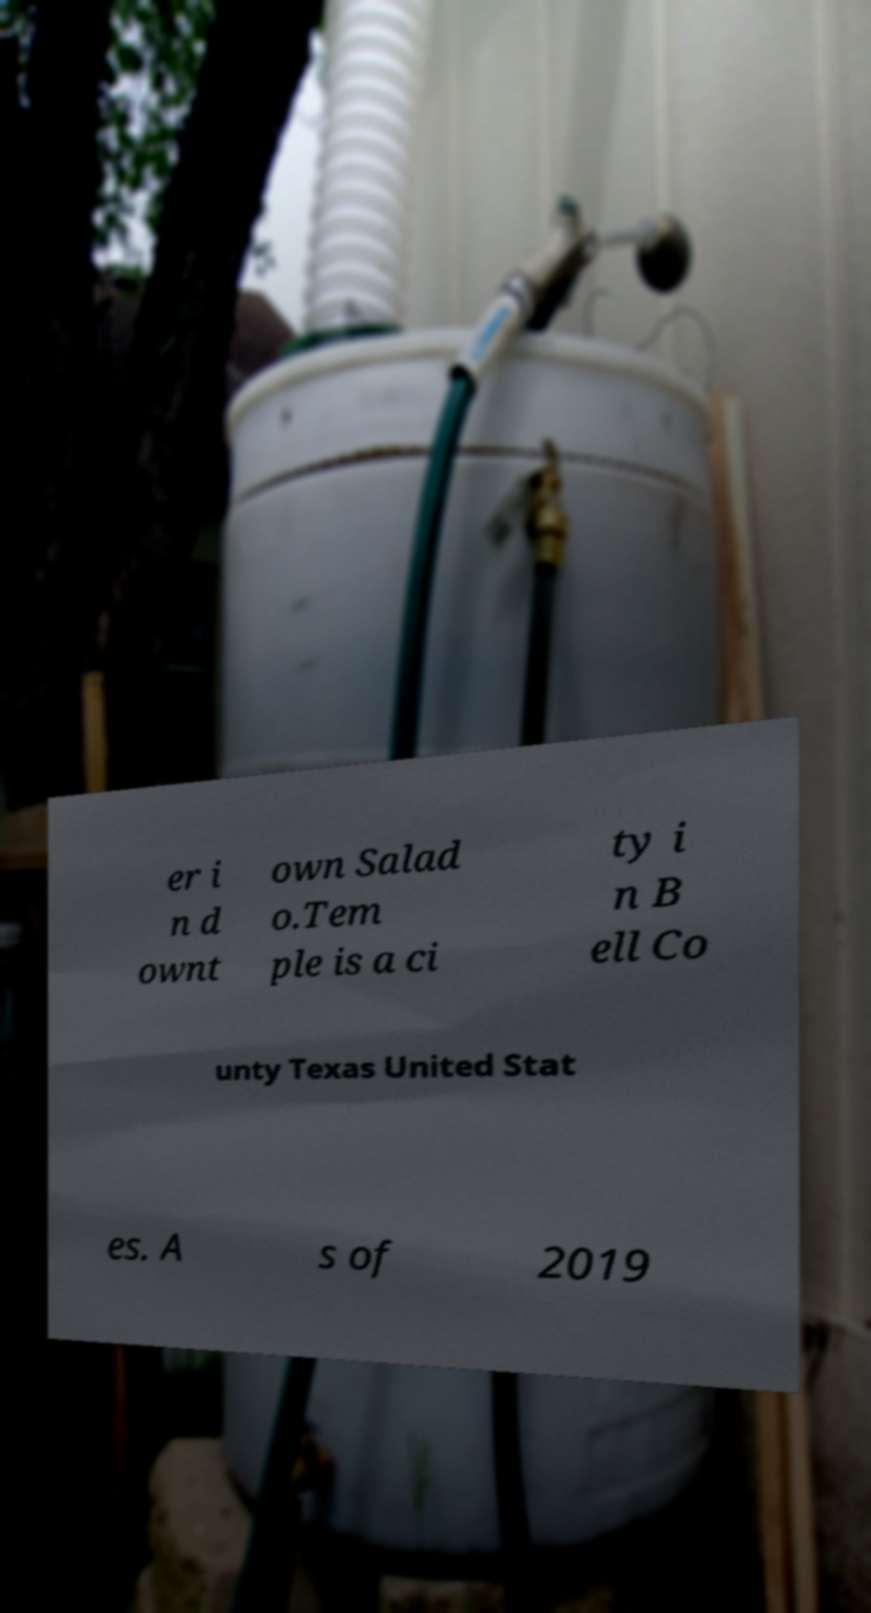Can you accurately transcribe the text from the provided image for me? er i n d ownt own Salad o.Tem ple is a ci ty i n B ell Co unty Texas United Stat es. A s of 2019 